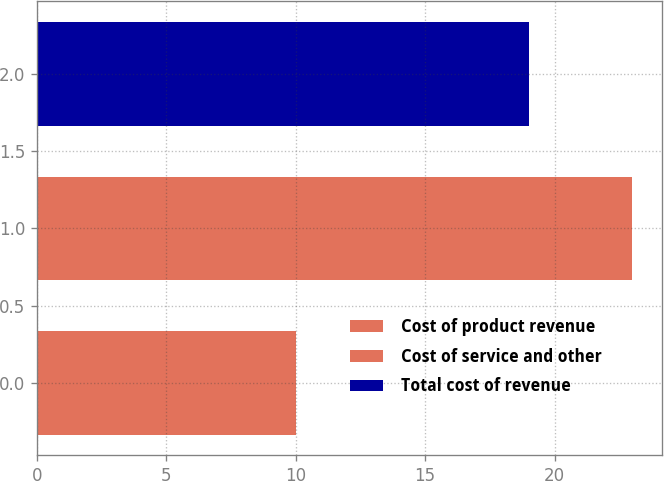Convert chart to OTSL. <chart><loc_0><loc_0><loc_500><loc_500><bar_chart><fcel>Cost of product revenue<fcel>Cost of service and other<fcel>Total cost of revenue<nl><fcel>10<fcel>23<fcel>19<nl></chart> 